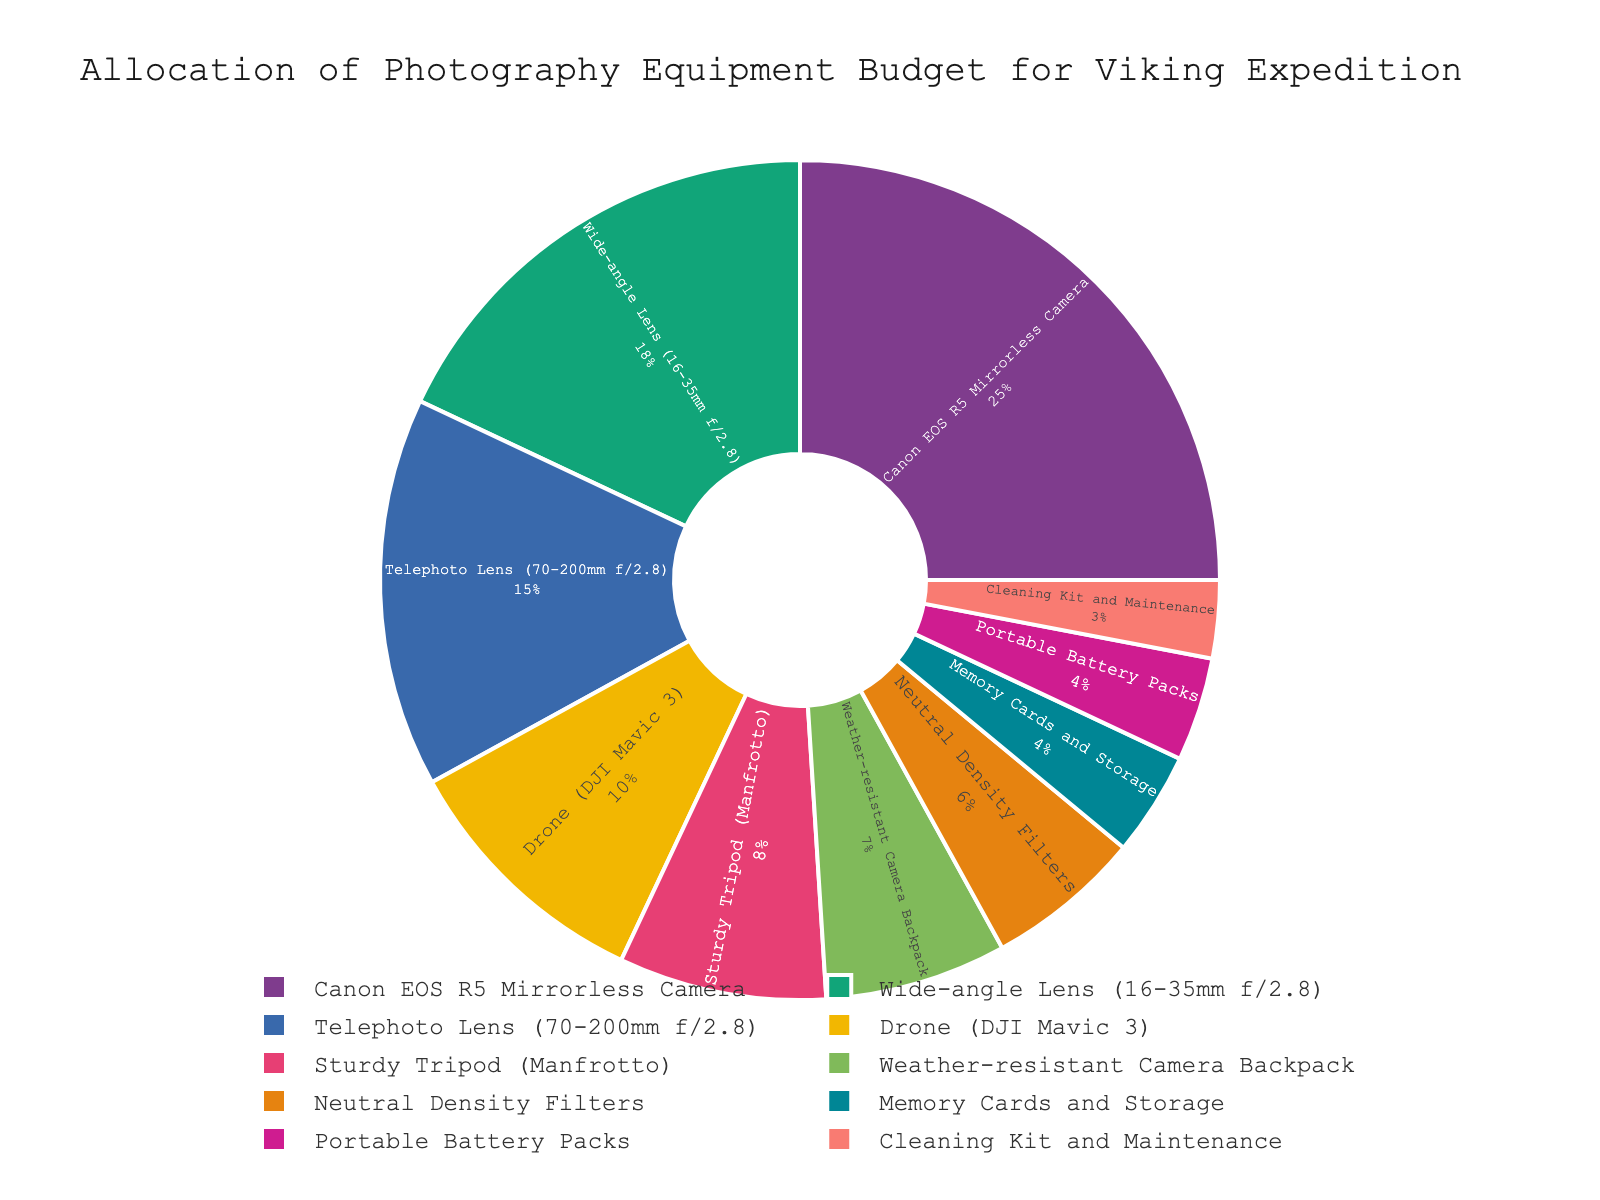Which category has the highest budget allocation? By examining the pie chart, notice which segment occupies the largest area. The "Canon EOS R5 Mirrorless Camera" segment is the largest.
Answer: Canon EOS R5 Mirrorless Camera How much larger is the budget allocation for the Canon EOS R5 Mirrorless Camera compared to the Wide-angle Lens (16-35mm f/2.8)? Look at the budget allocation for both categories: Canon EOS R5 Mirrorless Camera is 25%, and Wide-angle Lens is 18%. Subtract 18% from 25% to find the difference.
Answer: 7% What percentage of the budget is allocated to both the Drone (DJI Mavic 3) and Telephoto Lens (70-200mm f/2.8) combined? The Drone (DJI Mavic 3) has 10%, and the Telephoto Lens (70-200mm f/2.8) has 15%. Add these two percentages together to get the total.
Answer: 25% Which item has the smallest budget allocation, and what percentage of the budget does it represent? Identify the smallest segment in the pie chart. The "Cleaning Kit and Maintenance" segment is the smallest, at 3%.
Answer: Cleaning Kit and Maintenance, 3% What is the difference in budget allocation between the Sturdy Tripod (Manfrotto) and the Portable Battery Packs? The Sturdy Tripod (Manfrotto) has 8%, and the Portable Battery Packs have 4%. Subtract 4% from 8% to find the difference.
Answer: 4% Are there more budget allocations for lenses (both Wide-angle and Telephoto) or for accessories (sum of Sturdy Tripod, Weather-resistant Camera Backpack, Neutral Density Filters, Cleaning Kit and Maintenance, and Portable Battery Packs)? Add the percentages for lenses: Wide-angle Lens (18%) + Telephoto Lens (15%) = 33%. Now add the percentages for accessories: Sturdy Tripod (8%) + Weather-resistant Camera Backpack (7%) + Neutral Density Filters (6%) + Cleaning Kit and Maintenance (3%) + Portable Battery Packs (4%) = 28%. Compare the two sums.
Answer: Lenses, 33% Which category occupies a visually distinct green color, and what is its budget allocation? Identify the segment in green color on the pie chart, which corresponds to the Drone (DJI Mavic 3).
Answer: Drone (DJI Mavic 3), 10% How do the combined budget allocations for the Neutral Density Filters and Memory Cards and Storage compare to the allocation for the Wide-angle Lens (16-35mm f/2.8)? Add the percentages for Neutral Density Filters (6%) and Memory Cards and Storage (4%): 6% + 4% = 10%. The Wide-angle Lens (16-35mm f/2.8) has 18%, which is greater than the combined total for the filters and storage.
Answer: Less, 10% vs 18% What is the total budget allocation percentage for items related to power supply and storage? Add the percentages for Portable Battery Packs (4%) and Memory Cards and Storage (4%): 4% + 4% = 8%.
Answer: 8% Compare the budget allocation for the Telephoto Lens (70-200mm f/2.8) with the combined allocation for the Drone (DJI Mavic 3) and Neutral Density Filters. Which is higher? The Telephoto Lens is allocated 15%. The Drone (DJI Mavic 3) has 10% and the Neutral Density Filters 6%. Combined, the Drone and Neutral Density Filters have 10% + 6% = 16%, which is higher.
Answer: Combined allocation (16%) is higher 